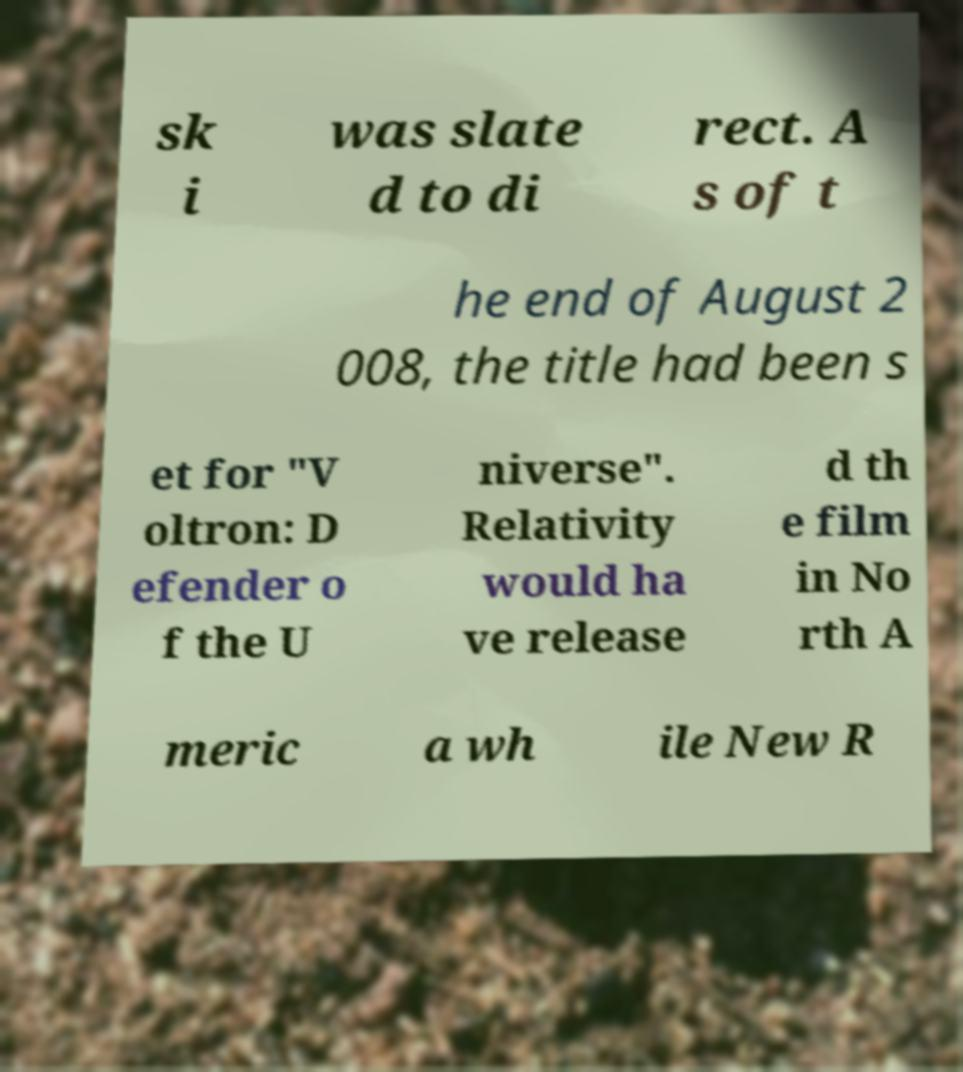Could you extract and type out the text from this image? sk i was slate d to di rect. A s of t he end of August 2 008, the title had been s et for "V oltron: D efender o f the U niverse". Relativity would ha ve release d th e film in No rth A meric a wh ile New R 